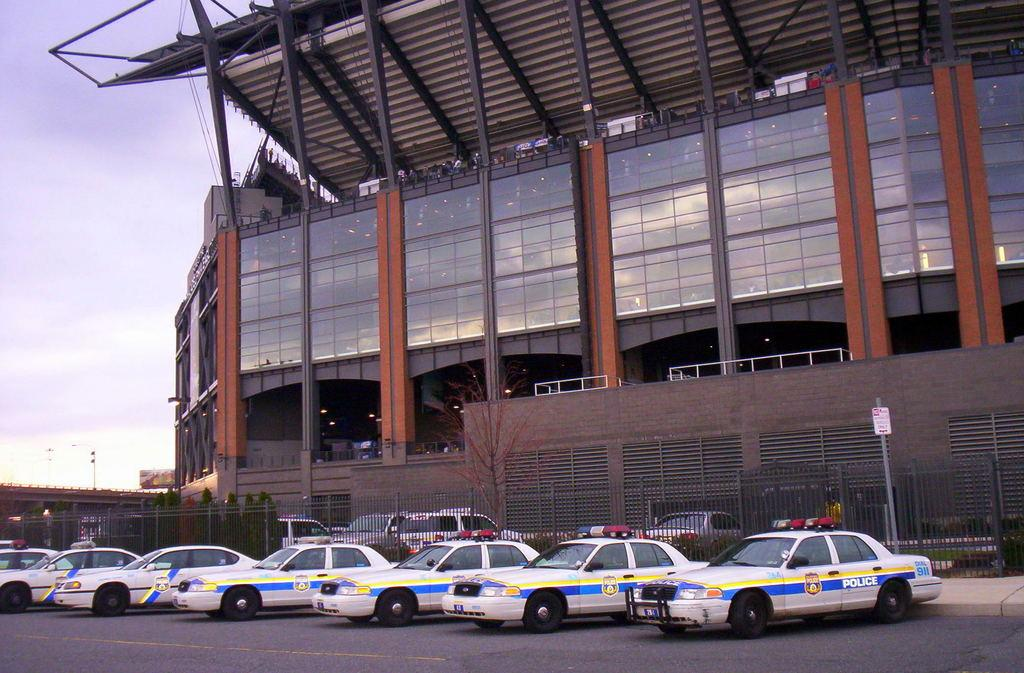What can be seen on the road in the image? There are vehicles on the road in the image. What is visible in the background of the image? There is a building in the background of the image. What is the purpose of the board visible in the image? The purpose of the board is not clear from the image, but it could be a sign or advertisement. What type of structures are present in the image? There are poles and a fence in the image. What type of vegetation is present in the image? There are trees in the image. What is visible at the top of the image? The sky is visible at the top of the image. What type of hot pie is being served at the restaurant in the image? There is no restaurant or pie present in the image. What type of apparel is being worn by the people in the image? There are no people visible in the image. 